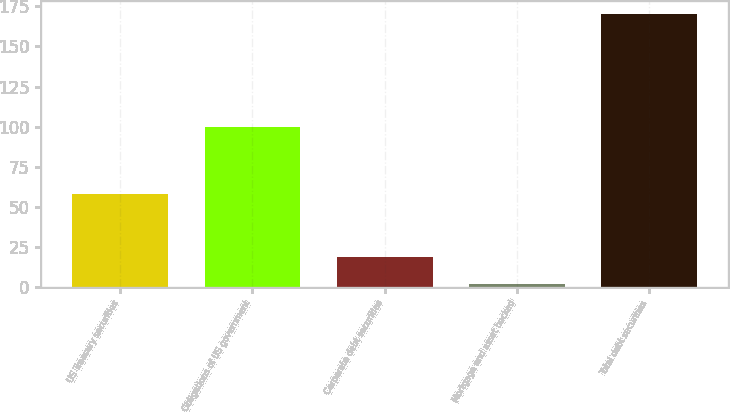Convert chart to OTSL. <chart><loc_0><loc_0><loc_500><loc_500><bar_chart><fcel>US Treasury securities<fcel>Obligations of US government<fcel>Corporate debt securities<fcel>Mortgage and asset backed<fcel>Total debt securities<nl><fcel>58<fcel>100<fcel>18.8<fcel>2<fcel>170<nl></chart> 